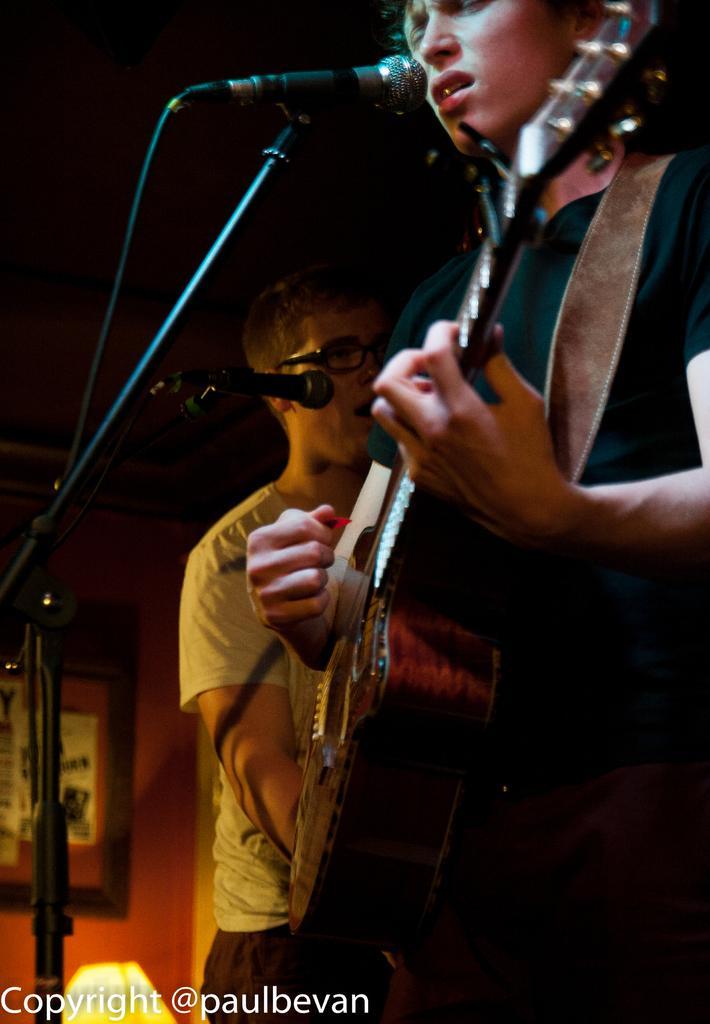In one or two sentences, can you explain what this image depicts? In this image i can see a person holding a guitar in his hand and another person standing beside him, and i can see microphones in front of them. 